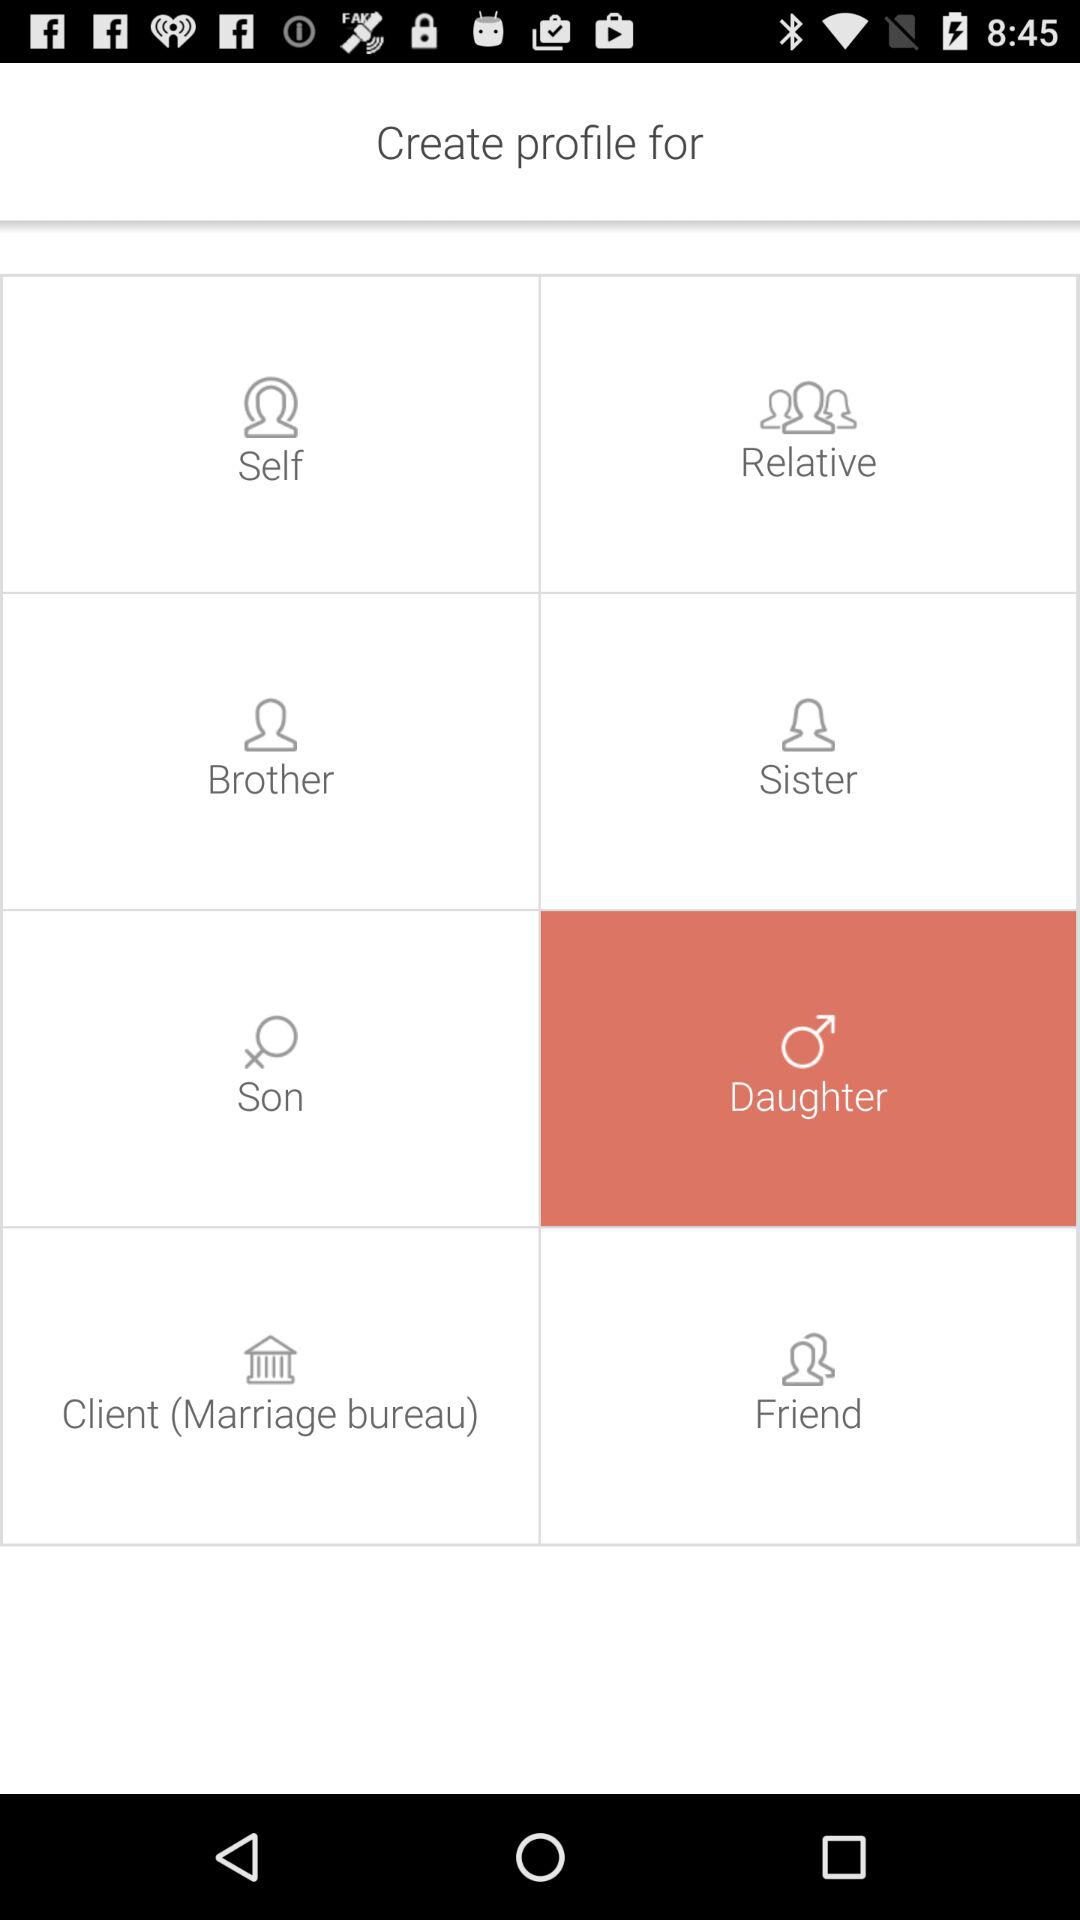Which option is selected? The selected option is "Daughter". 